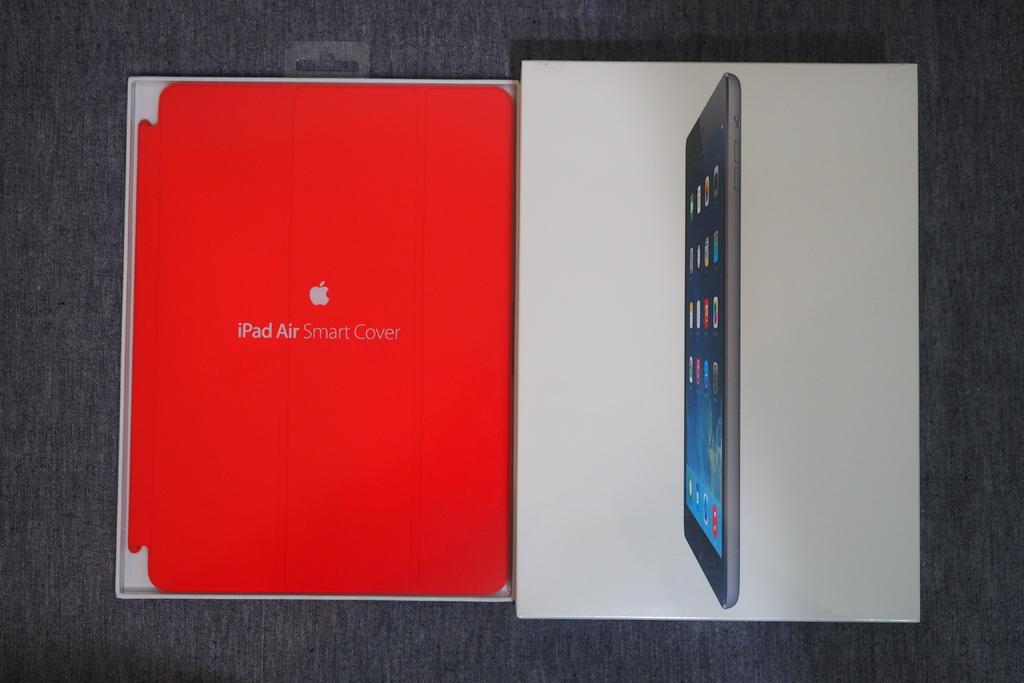<image>
Summarize the visual content of the image. The iPad Air from Apple comes with a nice orange Smart Cover. 